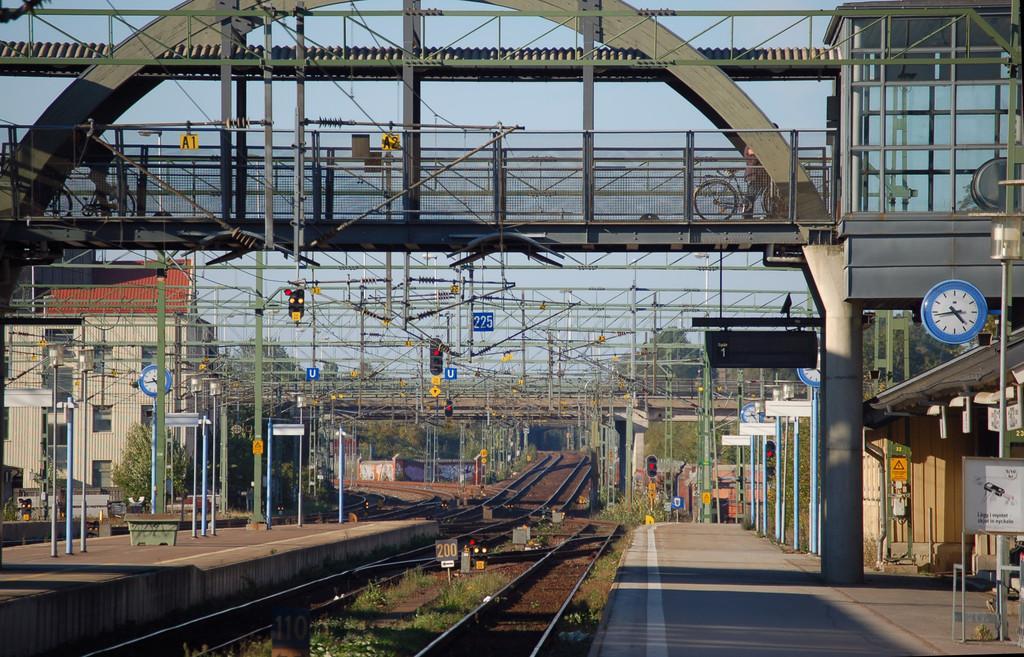How would you summarize this image in a sentence or two? In this image I can see few railway tracks on the ground, platforms on both sides of the tracks, few metal poles, a bridge, few persons riding bicycles on the bridge, few clocks which are white and blue in color, few boards, a traffic signal, few buildings and few trees. In the background I can see the sky. 